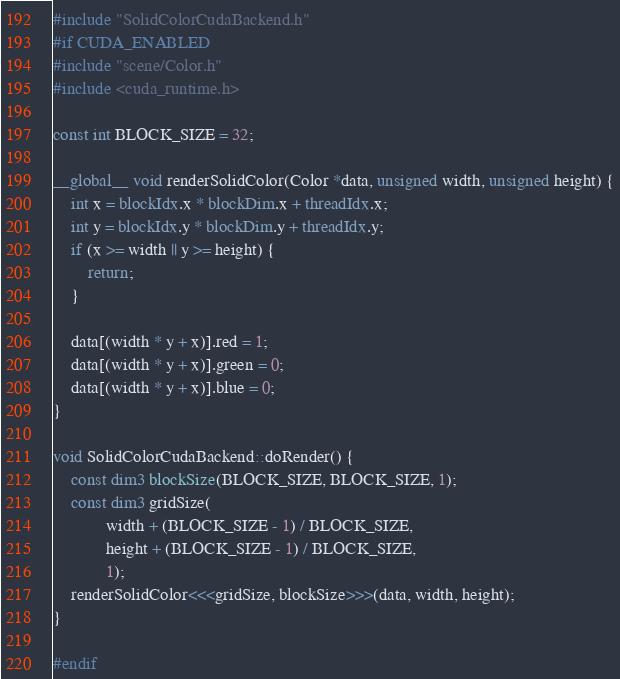Convert code to text. <code><loc_0><loc_0><loc_500><loc_500><_Cuda_>#include "SolidColorCudaBackend.h"
#if CUDA_ENABLED
#include "scene/Color.h"
#include <cuda_runtime.h>

const int BLOCK_SIZE = 32;

__global__ void renderSolidColor(Color *data, unsigned width, unsigned height) {
    int x = blockIdx.x * blockDim.x + threadIdx.x;
    int y = blockIdx.y * blockDim.y + threadIdx.y;
    if (x >= width || y >= height) {
        return;
    }

    data[(width * y + x)].red = 1;
    data[(width * y + x)].green = 0;
    data[(width * y + x)].blue = 0;
}

void SolidColorCudaBackend::doRender() {
    const dim3 blockSize(BLOCK_SIZE, BLOCK_SIZE, 1);
    const dim3 gridSize(
            width + (BLOCK_SIZE - 1) / BLOCK_SIZE,
            height + (BLOCK_SIZE - 1) / BLOCK_SIZE,
            1);
    renderSolidColor<<<gridSize, blockSize>>>(data, width, height);
}

#endif
</code> 